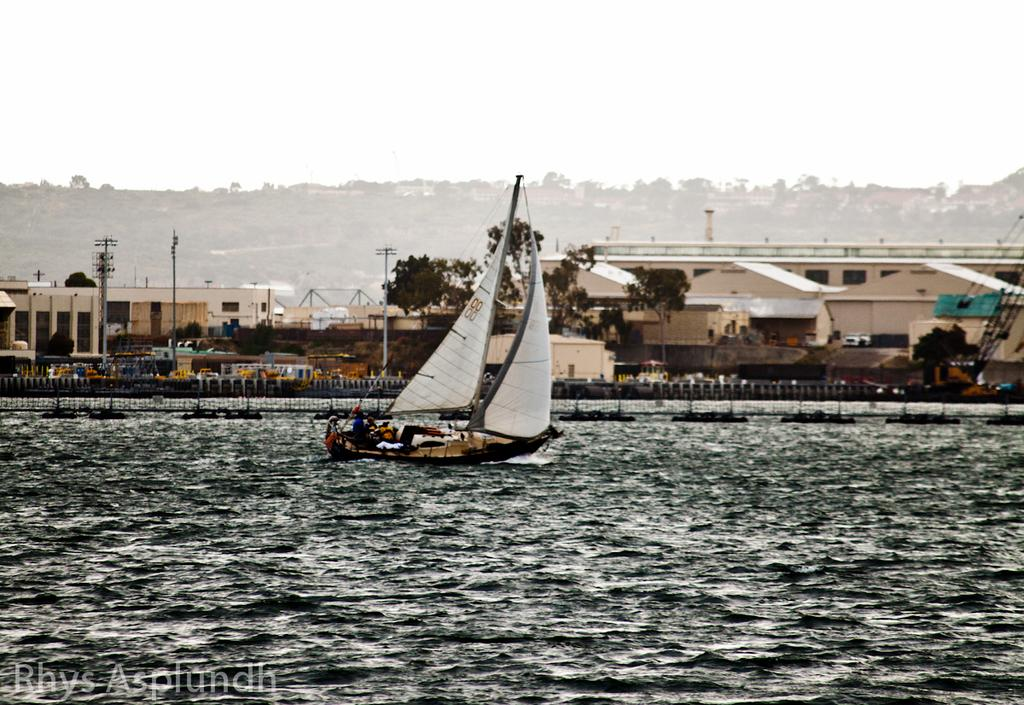What is located on the water in the image? There is a boat on the water in the image. What type of structure can be seen in the image? There is a fence in the image. What are the tall, thin objects in the image? There are poles in the image. What type of vegetation is present in the image? There are trees in the image. What type of man-made structures are visible in the image? There are buildings in the image. What is visible in the background of the image? The sky is visible in the background of the image. How many gloves can be seen hanging on the poles in the image? There are no gloves present in the image; it features a boat on the water, a fence, poles, trees, buildings, and a visible sky. What type of humor can be found in the image? There is no humor present in the image; it is a straightforward depiction of a boat on the water, surrounded by other objects and structures. 